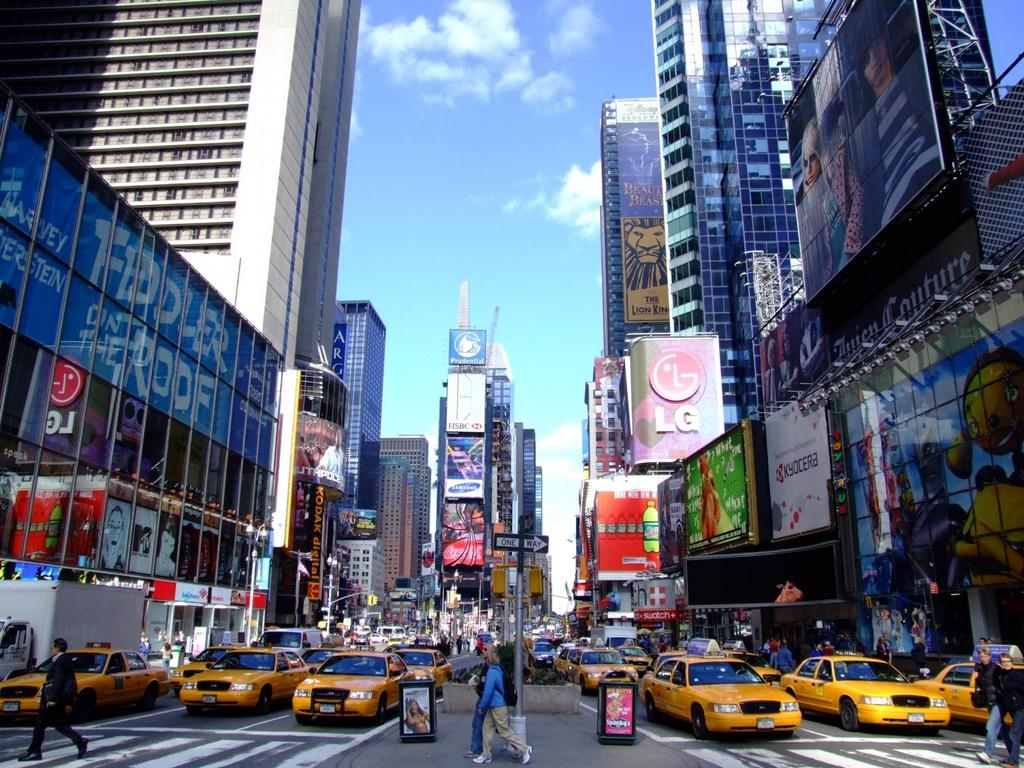<image>
Give a short and clear explanation of the subsequent image. Pedestrians are crossing a busy street filled with taxis under a sign that says The Lion King on building in the background. 